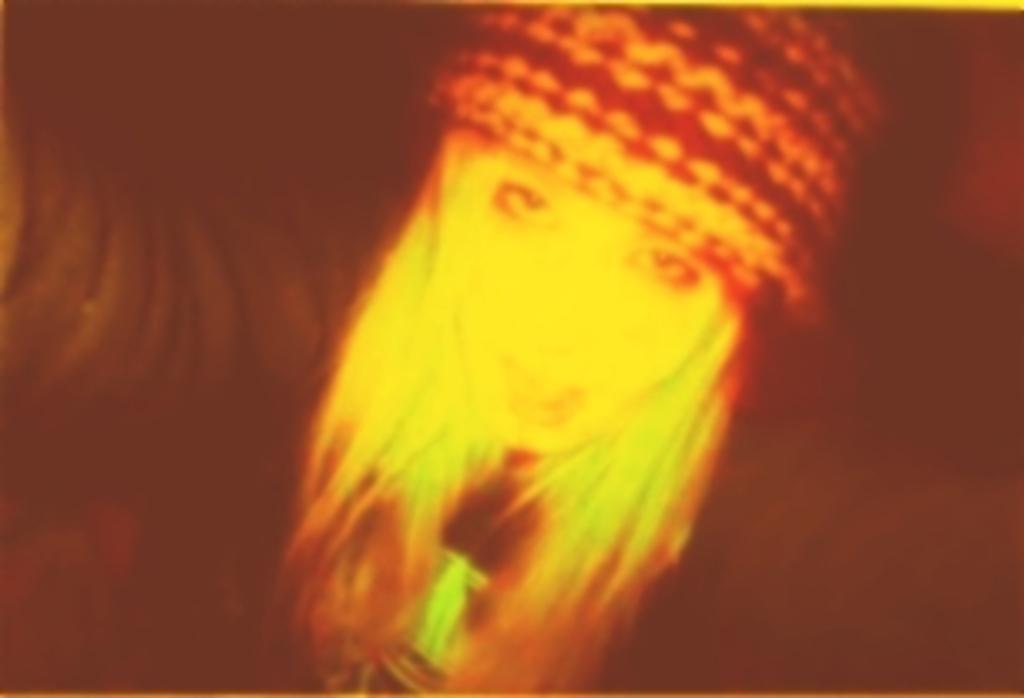Could you give a brief overview of what you see in this image? In the middle of the image, there is a person wearing a cap. And the background is dark in color. 